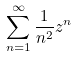<formula> <loc_0><loc_0><loc_500><loc_500>\sum _ { n = 1 } ^ { \infty } \frac { 1 } { n ^ { 2 } } z ^ { n }</formula> 